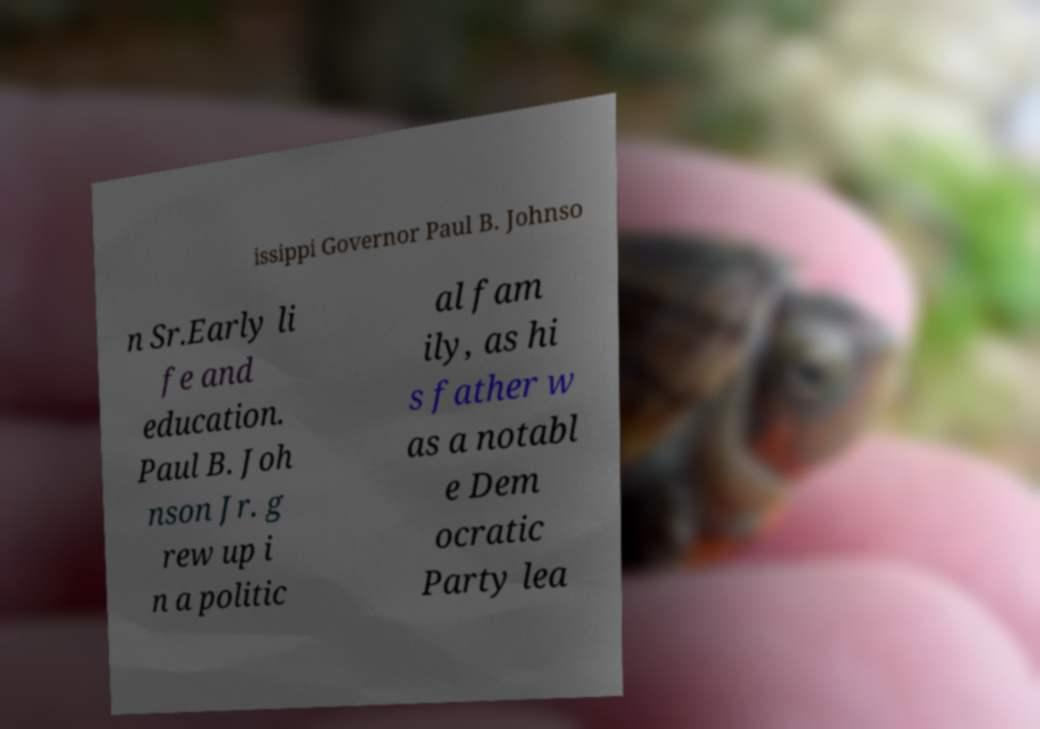I need the written content from this picture converted into text. Can you do that? issippi Governor Paul B. Johnso n Sr.Early li fe and education. Paul B. Joh nson Jr. g rew up i n a politic al fam ily, as hi s father w as a notabl e Dem ocratic Party lea 